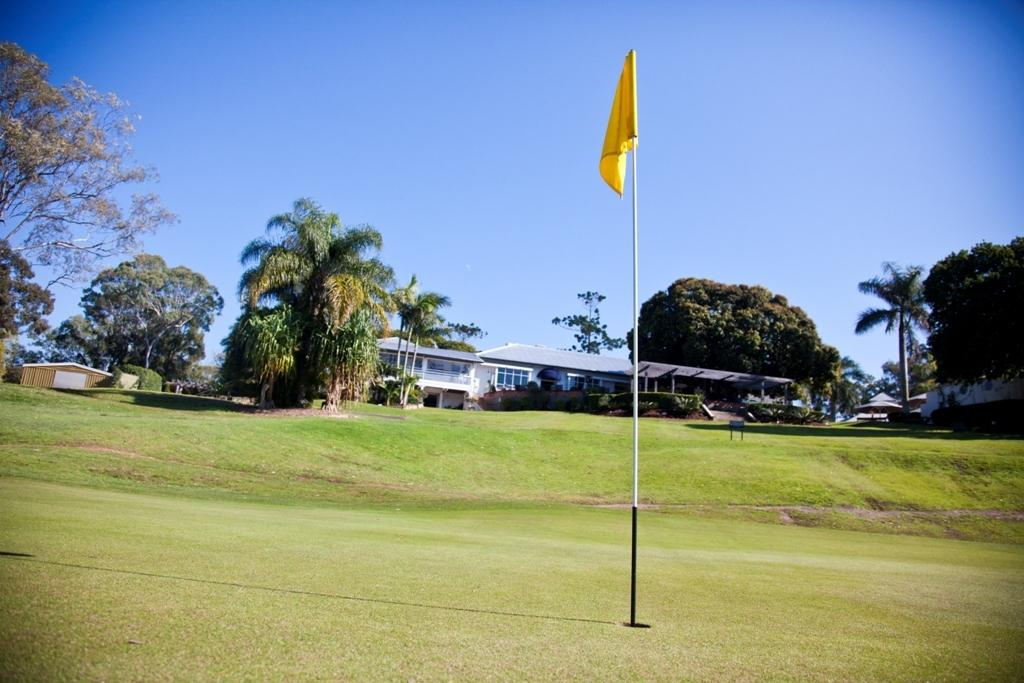What is the main color of the land in the image? There is a green land in the image. What is located in the middle of the green land? There is a flag in the middle of the green land. What can be seen in the background of the image? There are trees, houses, and the sky visible in the background of the image. What type of badge can be seen hanging from the flag in the image? There is no badge visible on the flag in the image. Can you tell me how many twigs are present in the image? There is no mention of twigs in the provided facts, so it cannot be determined how many twigs are present in the image. 